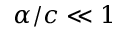<formula> <loc_0><loc_0><loc_500><loc_500>\alpha / c \ll 1</formula> 